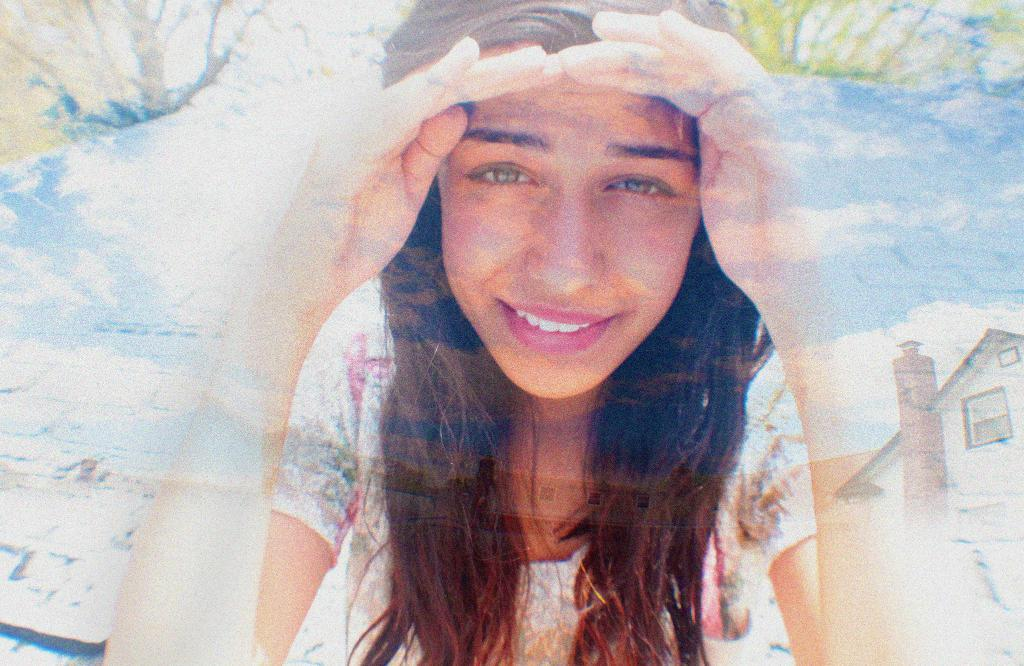What is the nature of the image? The image is edited. Who is the main subject in the image? There is a person in the center of the image. What is the person doing in the image? The person is smiling. What can be seen in the background of the image? There is sky visible in the image, with clouds present. What type of structures are visible in the image? There are buildings in the image. What type of friction can be observed between the person and the clouds in the image? There is no friction between the person and the clouds in the image, as they are separate elements in the scene. What kind of rice is being cooked in the image? There is no rice present in the image; it features a person, sky, clouds, and buildings. 